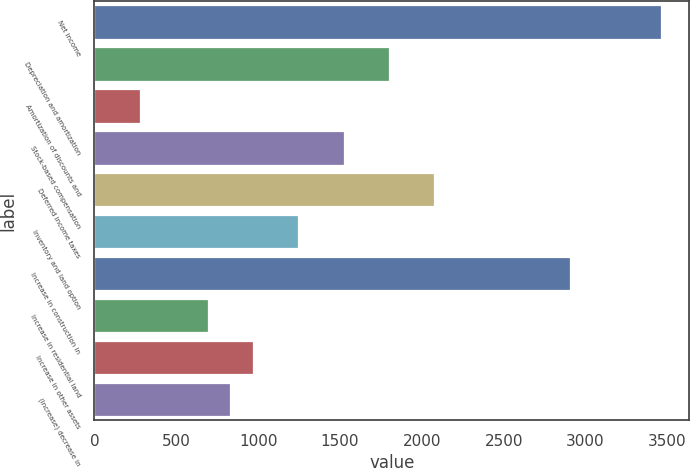Convert chart. <chart><loc_0><loc_0><loc_500><loc_500><bar_chart><fcel>Net income<fcel>Depreciation and amortization<fcel>Amortization of discounts and<fcel>Stock-based compensation<fcel>Deferred income taxes<fcel>Inventory and land option<fcel>Increase in construction in<fcel>Increase in residential land<fcel>Increase in other assets<fcel>(Increase) decrease in<nl><fcel>3459.2<fcel>1798.88<fcel>276.92<fcel>1522.16<fcel>2075.6<fcel>1245.44<fcel>2905.76<fcel>692<fcel>968.72<fcel>830.36<nl></chart> 